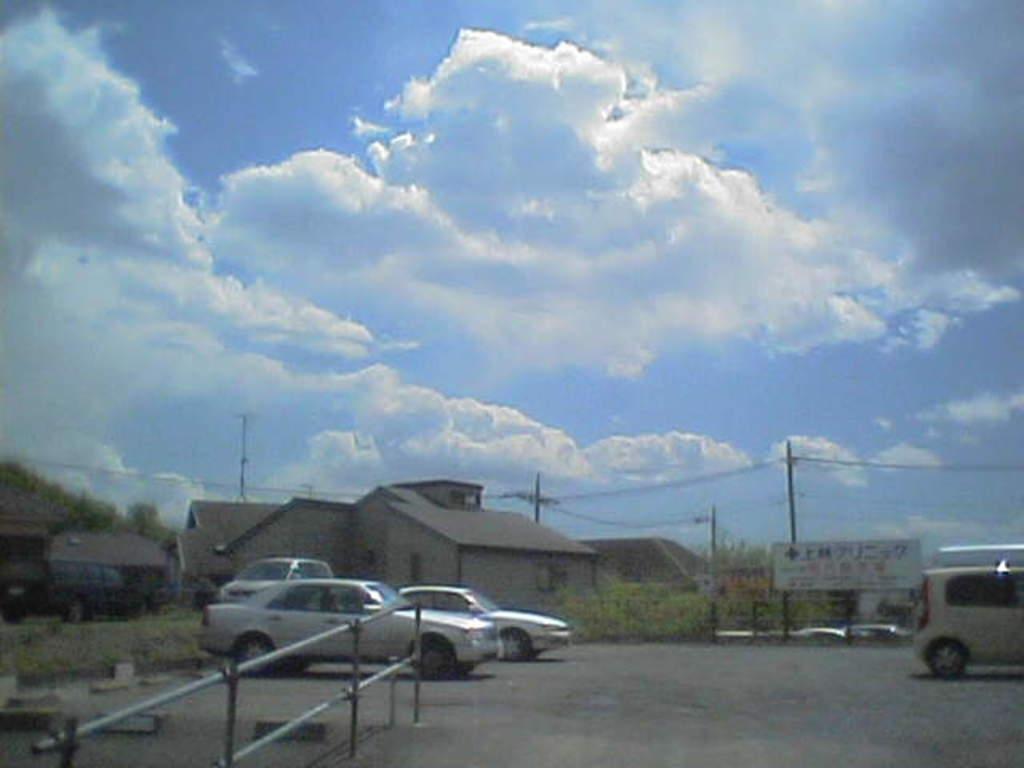How would you summarize this image in a sentence or two? In this image we can see some houses with roof and windows. We can also see some vehicles on the road, a metal fence, some plants, grass, trees, a signboard with some text on it, the utility poles with wires and the sky which looks cloudy. 